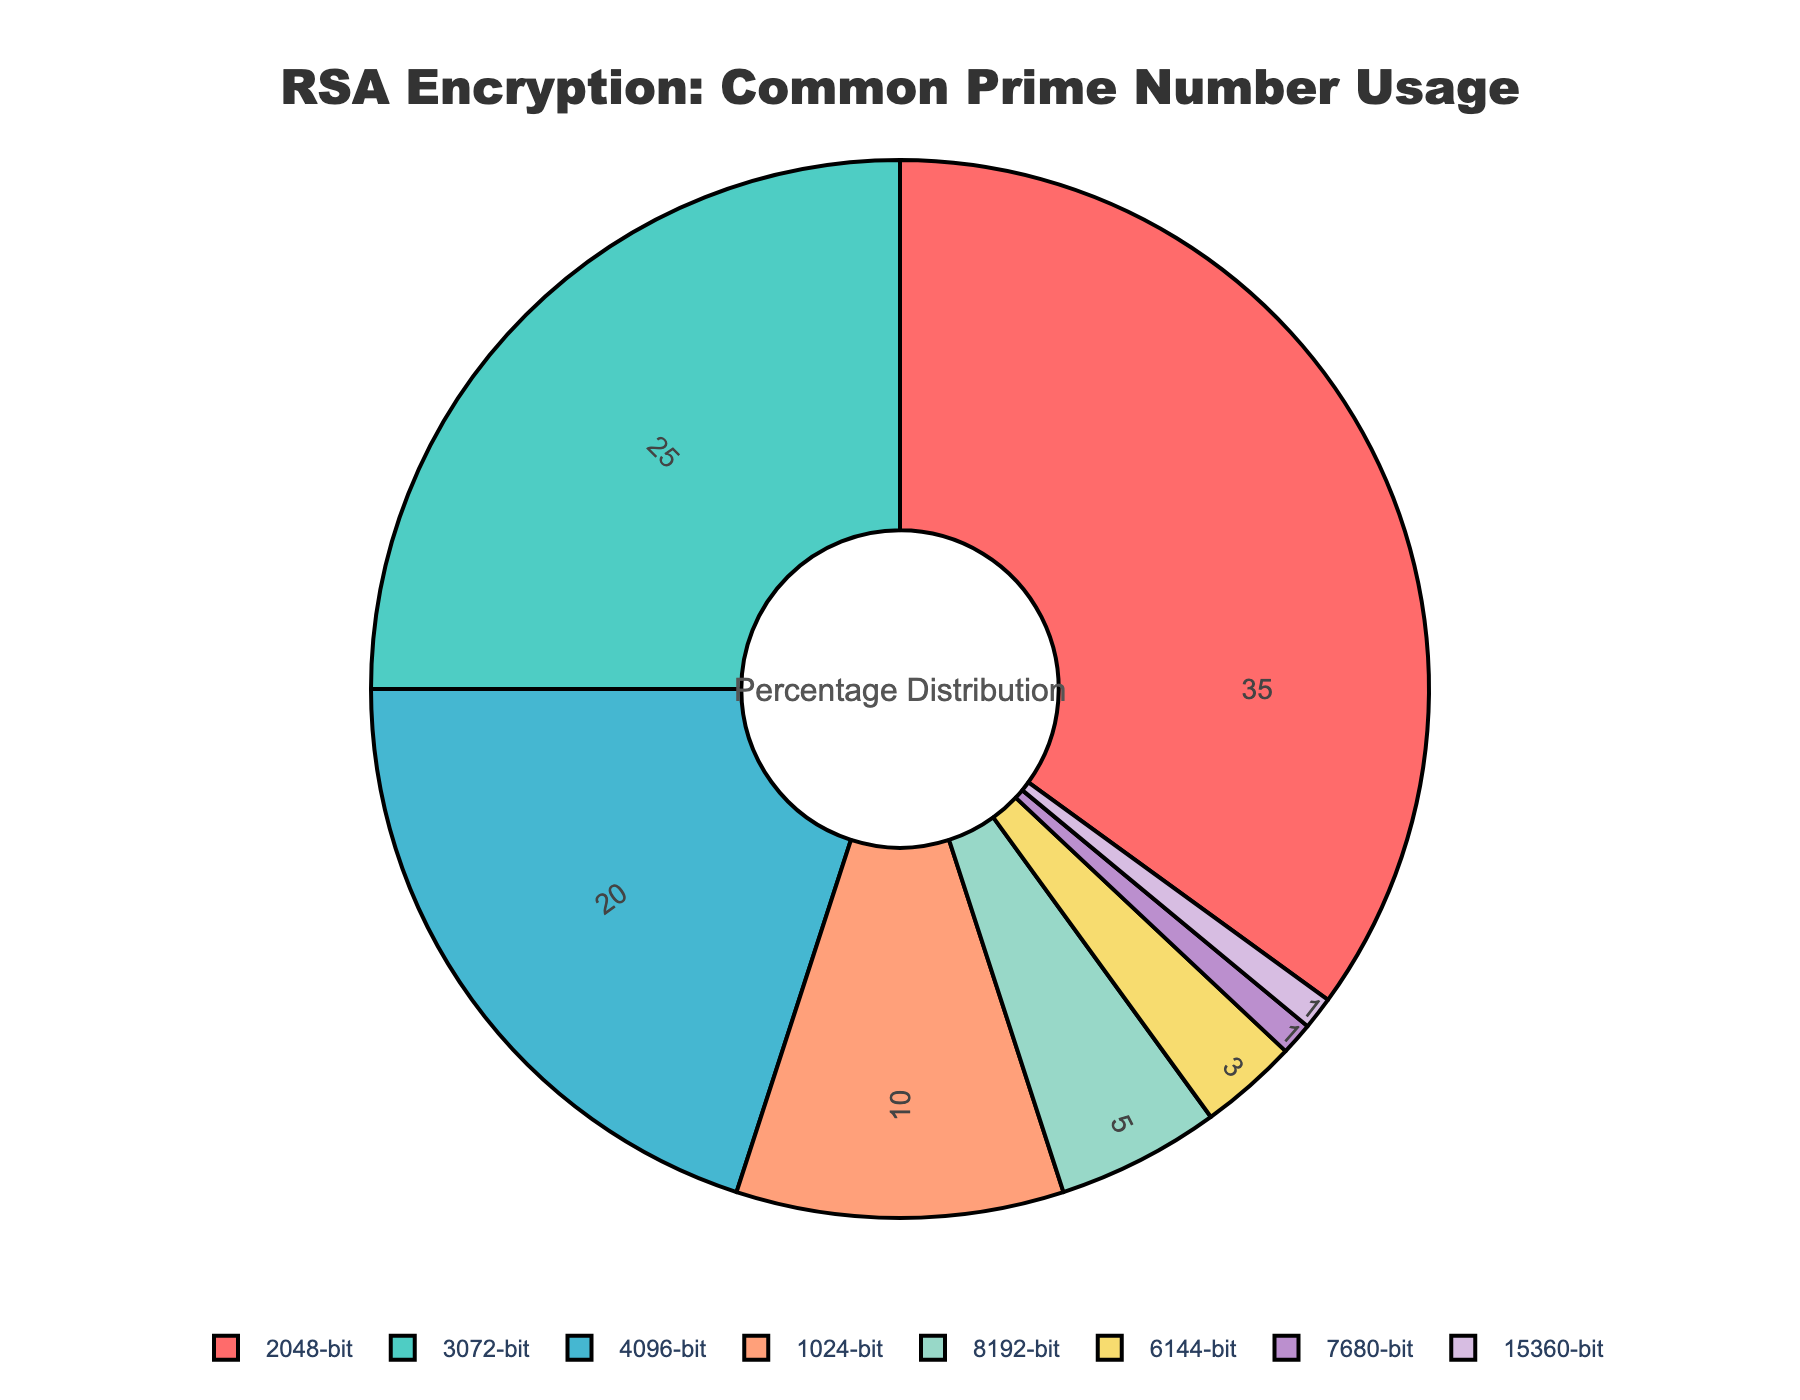What percentage of RSA usage involves prime numbers larger than 4096-bit? Add the usage percentages of all prime numbers larger than 4096-bit: 8192-bit (5%), 6144-bit (3%), 7680-bit (1%), 15360-bit (1%). So, 5% + 3% + 1% + 1% = 10%.
Answer: 10% Which prime number is most commonly used in RSA encryption? Look for the prime number with the largest usage percentage in the pie chart, which is 2048-bit at 35%.
Answer: 2048-bit How does the usage of 1024-bit prime numbers compare to 3072-bit prime numbers? The 1024-bit prime numbers have a usage percentage of 10%, while the 3072-bit prime numbers have a usage percentage of 25%. Therefore, the usage of 3072-bit prime numbers is higher.
Answer: 3072-bit is higher What is the combined usage percentage of 2048-bit and 4096-bit prime numbers? Add the usage percentages of 2048-bit (35%) and 4096-bit (20%): 35% + 20% = 55%.
Answer: 55% Which prime number has the lowest usage percentage and what is it? Identify the prime number with the smallest percentage in the chart, which is both the 7680-bit and 15360-bit prime numbers at 1% each.
Answer: 7680-bit, 15360-bit What is the difference in usage percentage between 6144-bit and 3072-bit prime numbers? Subtract the usage percentage of 6144-bit (3%) from that of 3072-bit (25%): 25% - 3% = 22%.
Answer: 22% What is the median usage percentage of the prime numbers used in RSA encryption? Arrange the usage percentages in ascending order: 1%, 1%, 3%, 5%, 10%, 20%, 25%, 35%. Since there are 8 values, the median is the average of the 4th and 5th values: (5% + 10%) / 2 = 7.5%.
Answer: 7.5% Which color represents the 2048-bit prime number usage in the pie chart? The 2048-bit prime number is represented by the first color in the list, which is red.
Answer: Red What's the range of usage percentages for the prime numbers? Subtract the smallest usage percentage (1%) from the largest usage percentage (35%): 35% - 1% = 34%.
Answer: 34% How many prime numbers have a usage percentage of more than 10%? Count the number of segments with percentages more than 10%: 2048-bit (35%), 3072-bit (25%), 4096-bit (20%). There are three such segments.
Answer: 3 